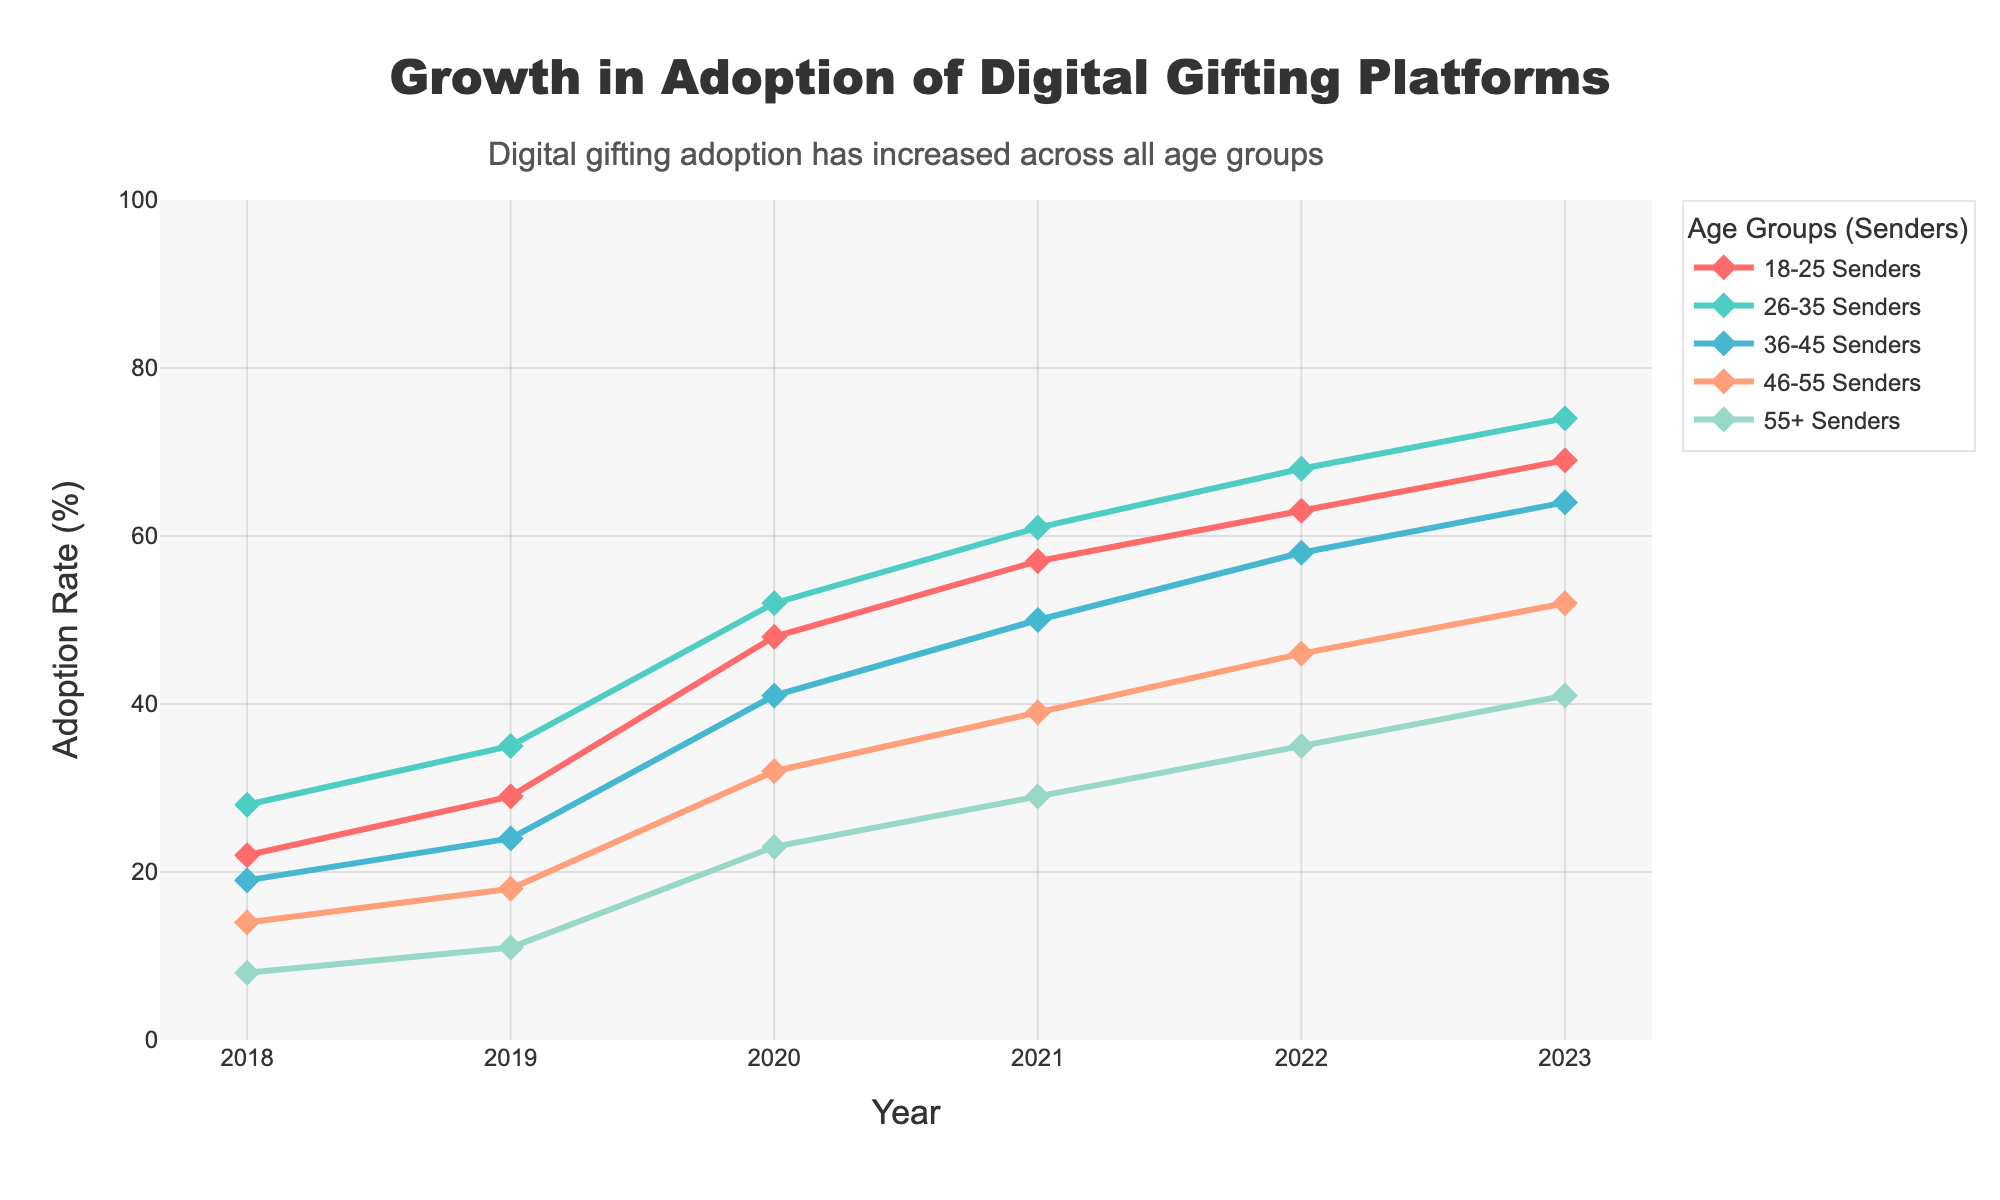What was the adoption rate for the 18-25 senders in 2020? Find the year 2020 on the x-axis and look for the point on the line labeled "18-25 Senders." The y-value corresponding to this point shows the adoption rate.
Answer: 48 How did the adoption rate for the 46-55 senders change from 2018 to 2023? Identify the y-values for the "46-55 Senders" group in the years 2018 and 2023. Subtract the former from the latter to find the change.
Answer: +38 Which age group of senders had the highest adoption rate in 2021? For the year 2021, compare the y-values for all age groups and identify the highest one.
Answer: 26-35 Senders What is the average adoption rate for the 36-45 senders over the period 2018-2023? Sum the y-values for "36-45 Senders" from 2018 to 2023 and divide by 6 (the number of years).
Answer: 42.67 Between which consecutive years did the 26-35 senders see the largest increase in adoption rate? Calculate the difference in y-values for "26-35 Senders" between each pair of consecutive years (i.e., 2018-2019, 2019-2020, etc.) and compare the differences.
Answer: 2019-2020 Which age group had the least adoption rate in 2022? For the year 2022, compare the y-values for all age groups and identify the smallest one.
Answer: 55+ Senders What was the overall trend in digital gifting adoption for the 55+ senders from 2018 to 2023? Observe the line representing "55+ Senders" from 2018 to 2023. Note whether it is increasing, decreasing, or remaining constant over the years.
Answer: Increasing How much higher was the adoption rate for the 26-35 senders compared to the 18-25 senders in 2023? Subtract the y-value for "18-25 Senders" from the y-value for "26-35 Senders" in the year 2023.
Answer: 5 Which two age groups had the closest adoption rates in 2019? For the year 2019, compare the y-values for all age groups and identify the two groups with the smallest difference.
Answer: 36-45 Senders and 46-55 Senders Identify one age group whose adoption rate consistently increased every year from 2018 to 2023. Observe the y-values over the years for each age group and find one where the value increases each successive year.
Answer: 26-35 Senders 